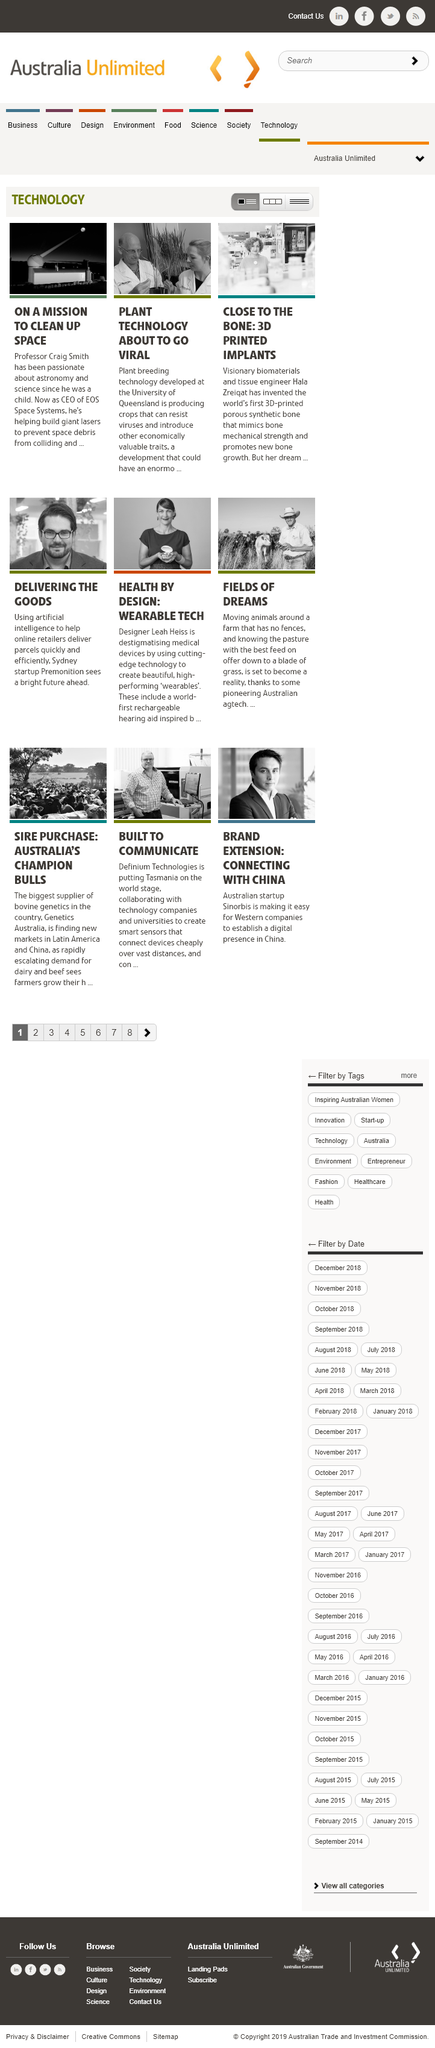Give some essential details in this illustration. I, Hala Zreiqat, am a visionary biomaterials and tissue engineer. The University of Queensland has developed plant breeding technology that is considered to be among the most advanced in the world. Professor Craig Smith has been passionate about astronomy and science since he was a child. 